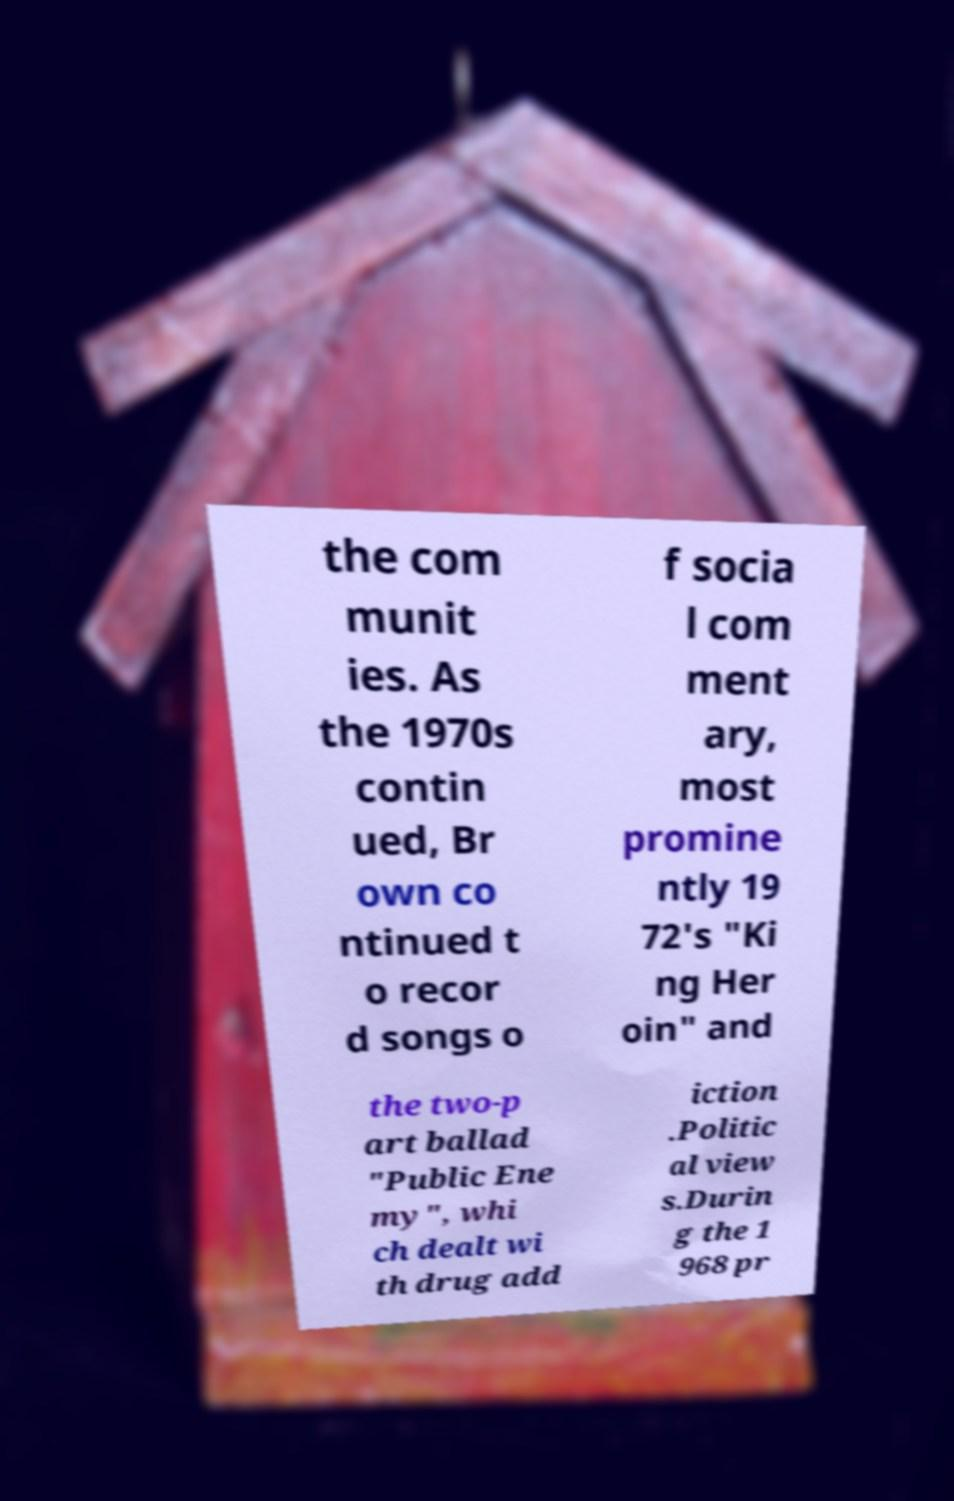Could you assist in decoding the text presented in this image and type it out clearly? the com munit ies. As the 1970s contin ued, Br own co ntinued t o recor d songs o f socia l com ment ary, most promine ntly 19 72's "Ki ng Her oin" and the two-p art ballad "Public Ene my", whi ch dealt wi th drug add iction .Politic al view s.Durin g the 1 968 pr 